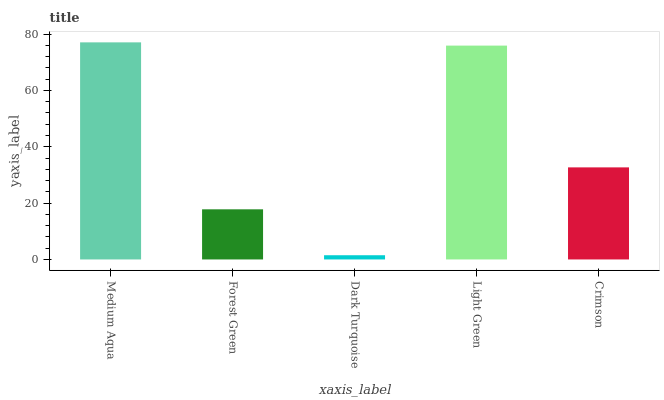Is Dark Turquoise the minimum?
Answer yes or no. Yes. Is Medium Aqua the maximum?
Answer yes or no. Yes. Is Forest Green the minimum?
Answer yes or no. No. Is Forest Green the maximum?
Answer yes or no. No. Is Medium Aqua greater than Forest Green?
Answer yes or no. Yes. Is Forest Green less than Medium Aqua?
Answer yes or no. Yes. Is Forest Green greater than Medium Aqua?
Answer yes or no. No. Is Medium Aqua less than Forest Green?
Answer yes or no. No. Is Crimson the high median?
Answer yes or no. Yes. Is Crimson the low median?
Answer yes or no. Yes. Is Medium Aqua the high median?
Answer yes or no. No. Is Light Green the low median?
Answer yes or no. No. 